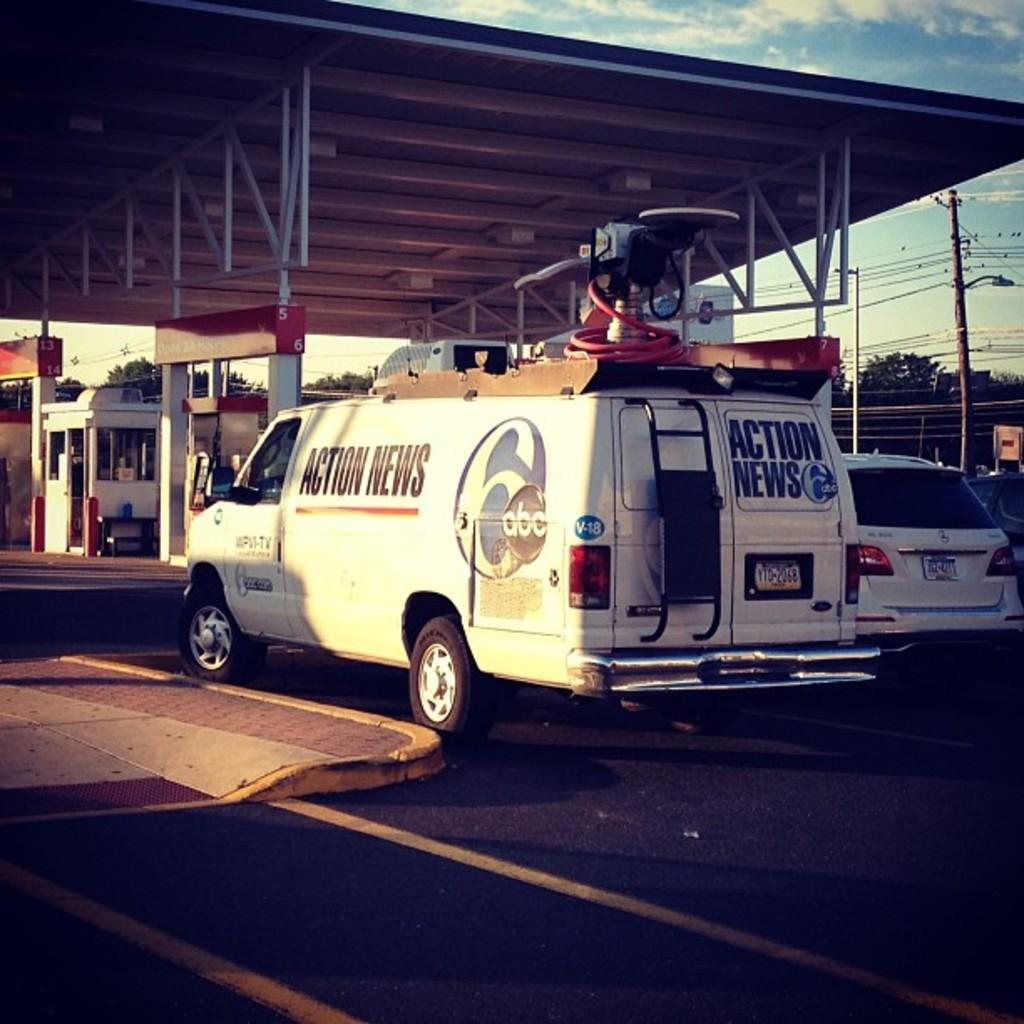<image>
Provide a brief description of the given image. A news truck is parked outside of a gas station. 